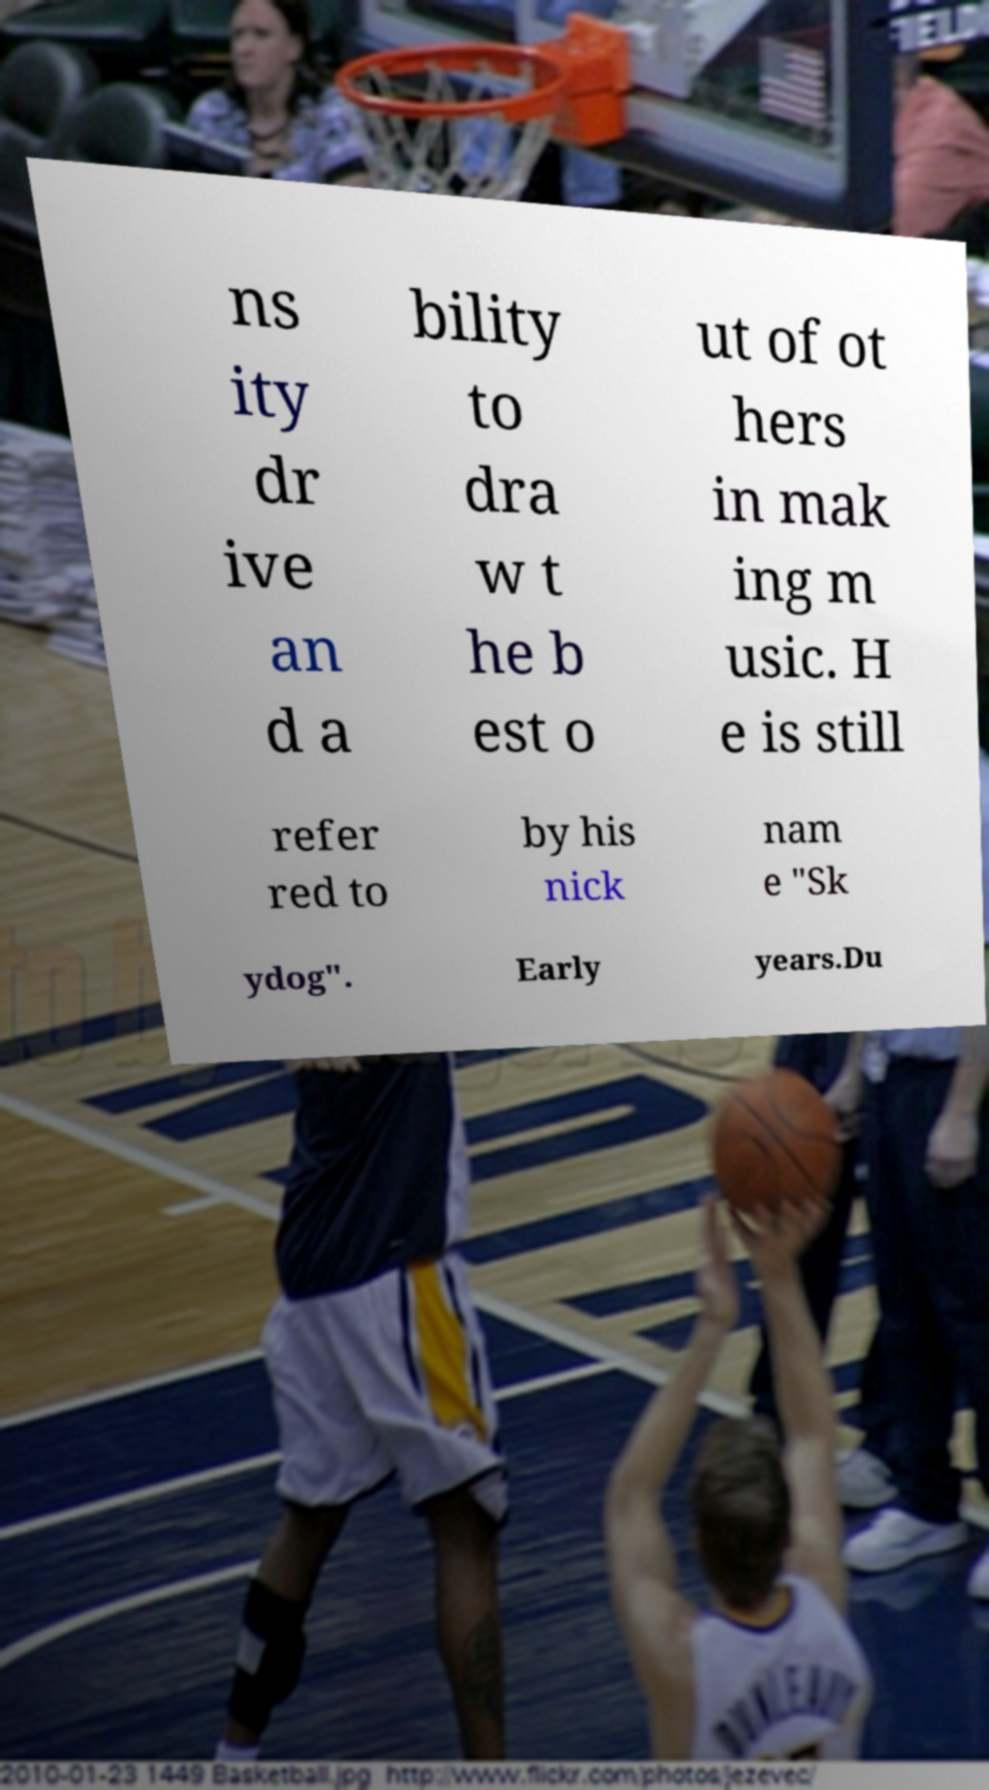There's text embedded in this image that I need extracted. Can you transcribe it verbatim? ns ity dr ive an d a bility to dra w t he b est o ut of ot hers in mak ing m usic. H e is still refer red to by his nick nam e "Sk ydog". Early years.Du 